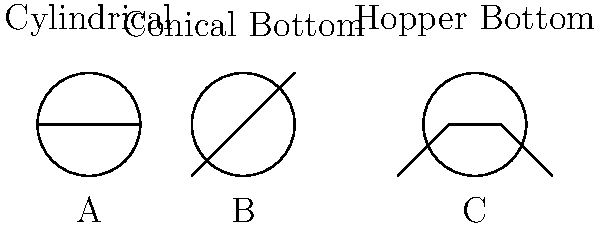As a farmer considering different silo designs for storing your crops, which of the above cross-sectional designs (A, B, or C) would be most effective in preventing moisture buildup and reducing the need for additional mechanical systems for crop removal? Let's analyze each silo design:

1. Design A (Cylindrical):
   - Simple design, but flat bottom can lead to moisture accumulation
   - Requires additional mechanical systems for complete emptying

2. Design B (Conical Bottom):
   - Sloped bottom helps with gravity flow
   - Reduces moisture buildup compared to flat bottom
   - May still require some mechanical assistance for complete emptying

3. Design C (Hopper Bottom):
   - Steep angled bottom promotes better gravity flow
   - Significantly reduces moisture accumulation
   - Minimal or no mechanical systems needed for emptying

Step-by-step analysis:
1. Moisture prevention:
   C > B > A (C is best, A is worst)

2. Ease of crop removal:
   C > B > A (C is best, A is worst)

3. Cost-effectiveness:
   - C may have higher initial cost but lower operational costs
   - A has lower initial cost but higher operational costs
   - B is intermediate in both aspects

Considering these factors, Design C (Hopper Bottom) is the most effective in preventing moisture buildup and reducing the need for additional mechanical systems for crop removal. It provides better long-term storage conditions and operational efficiency, which can lead to economic benefits despite potentially higher initial costs.
Answer: Design C (Hopper Bottom) 